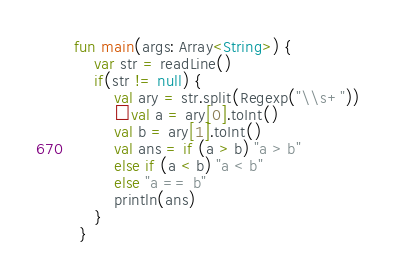<code> <loc_0><loc_0><loc_500><loc_500><_Kotlin_>fun main(args: Array<String>) {
    var str = readLine()
    if(str != null) {
        val ary = str.split(Regexp("\\s+"))
        val a = ary[0].toInt()
        val b = ary[1].toInt()
        val ans = if (a > b) "a > b"
        else if (a < b) "a < b"
        else "a == b"
        println(ans)
    }
 }
</code> 